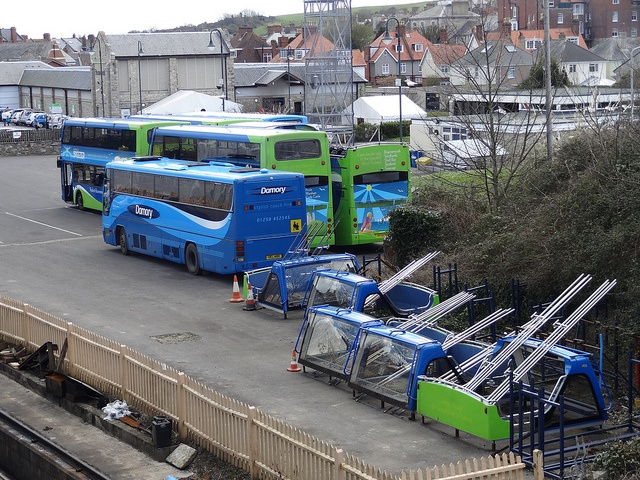Describe the objects in this image and their specific colors. I can see bus in white, blue, gray, darkblue, and navy tones, bus in white, green, gray, and black tones, bus in white, green, black, blue, and darkgreen tones, bus in white, black, blue, green, and navy tones, and bus in white, lightblue, darkgray, and lightgreen tones in this image. 